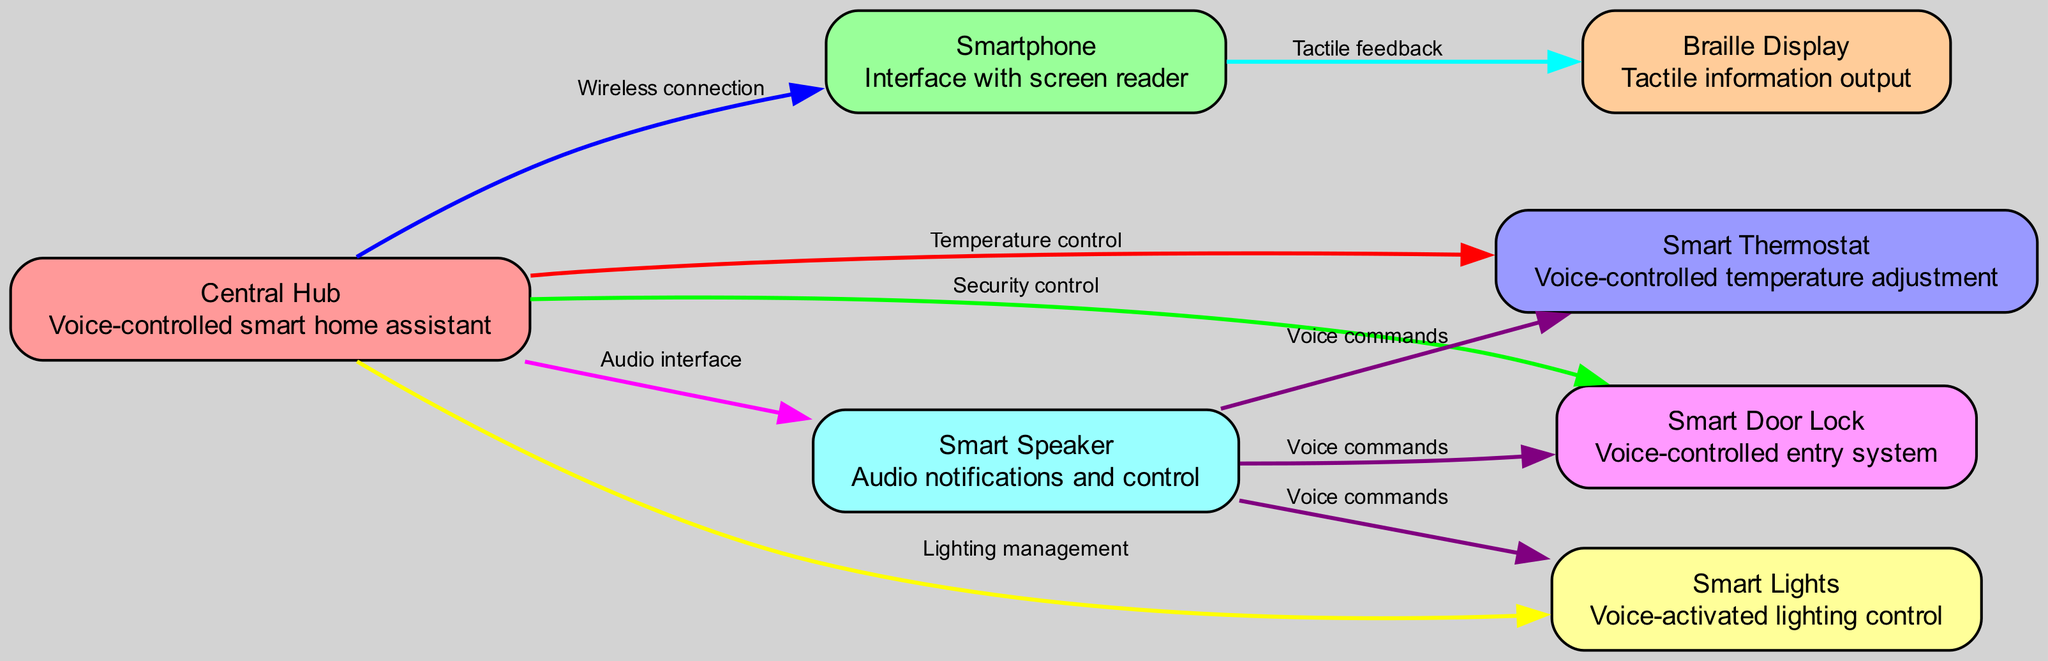What is the name of the node that represents the voice-controlled smart home assistant? The diagram has a node labeled "Central Hub" which is described as a voice-controlled smart home assistant. Therefore, the name of the node is "Central Hub."
Answer: Central Hub How many nodes are present in the diagram? By counting the items listed under the "nodes" key, there are seven distinct nodes represented in the diagram.
Answer: 7 What type of connection exists between the Central Hub and the Smartphone? The line or edge connecting the Central Hub to the Smartphone is labeled "Wireless connection," indicating the type of interconnection.
Answer: Wireless connection Which node provides tactile feedback? The node labeled "Braille Display" is described as providing tactile information output, indicating that it is responsible for tactile feedback.
Answer: Braille Display How many total edges are there in the diagram? By examining the "edges" section, there are a total of seven relationships or connections listed between the nodes, which constitute the edges in the diagram.
Answer: 7 What is the relationship between Smart Speaker and Smart Thermostat? The edge indicating the connection between the Smart Speaker and Smart Thermostat is labeled "Voice commands," which describes how they interact.
Answer: Voice commands Which device can be used to control security features in the smart home system? The "Smart Door Lock" node is connected to the Central Hub with an edge labeled "Security control," indicating that it pertains to controlling security features.
Answer: Smart Door Lock What is the main function of the Smart Lights node? The "Smart Lights" node description specifies that it is used for "Voice-activated lighting control," defining its main function.
Answer: Voice-activated lighting control If you wanted to adjust the temperature, which node would you interact with? The "Smart Thermostat" node is linked to the Central Hub with an edge labeled "Temperature control," indicating that it is the designated node for temperature adjustments.
Answer: Smart Thermostat What is the main output method of the Braille Display? The Braille Display is described as providing "Tactile information output," which refers to its main output method.
Answer: Tactile information output 